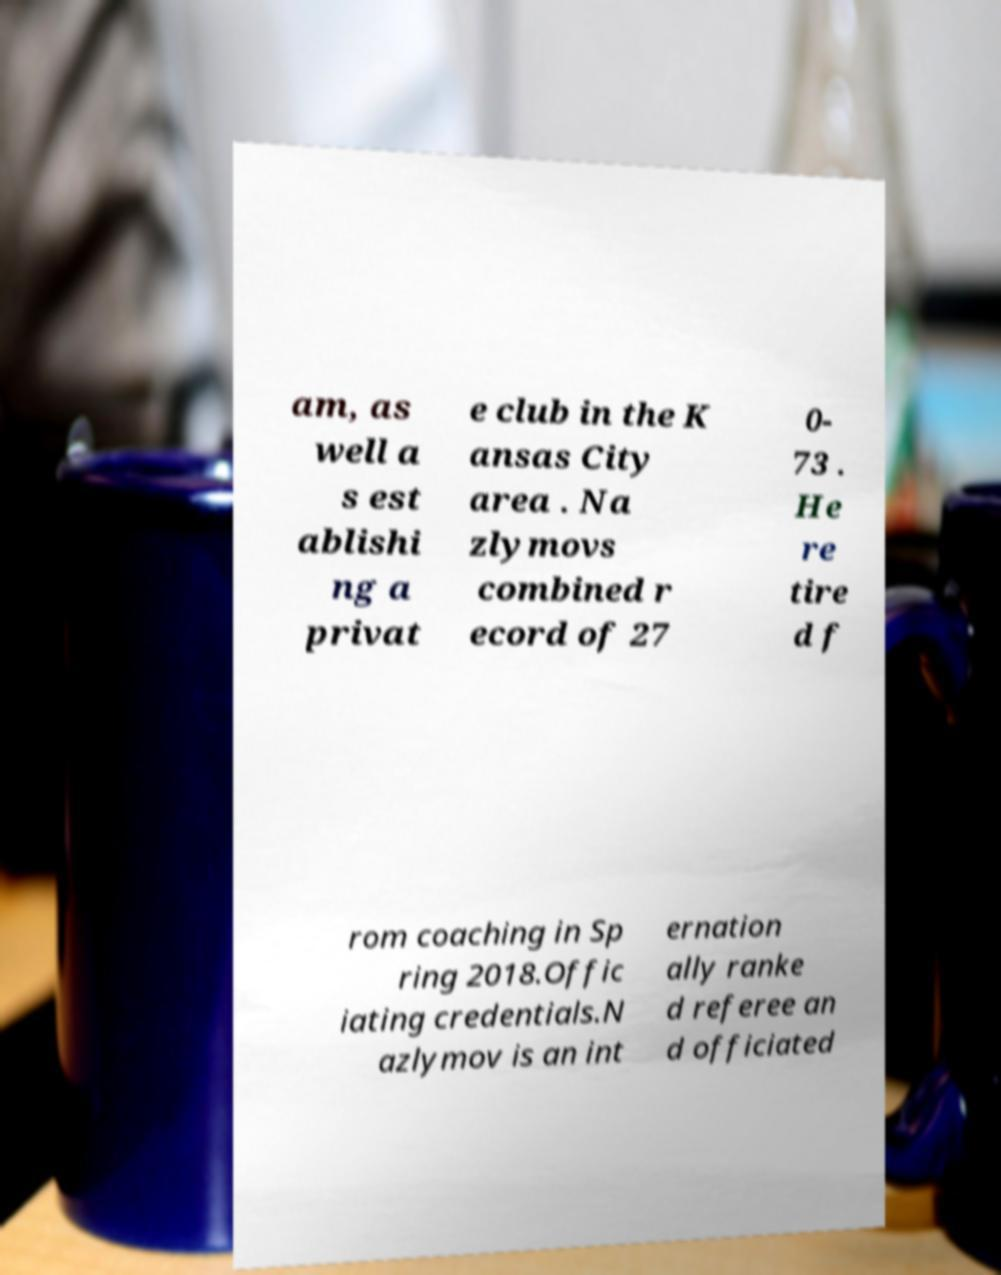What messages or text are displayed in this image? I need them in a readable, typed format. am, as well a s est ablishi ng a privat e club in the K ansas City area . Na zlymovs combined r ecord of 27 0- 73 . He re tire d f rom coaching in Sp ring 2018.Offic iating credentials.N azlymov is an int ernation ally ranke d referee an d officiated 